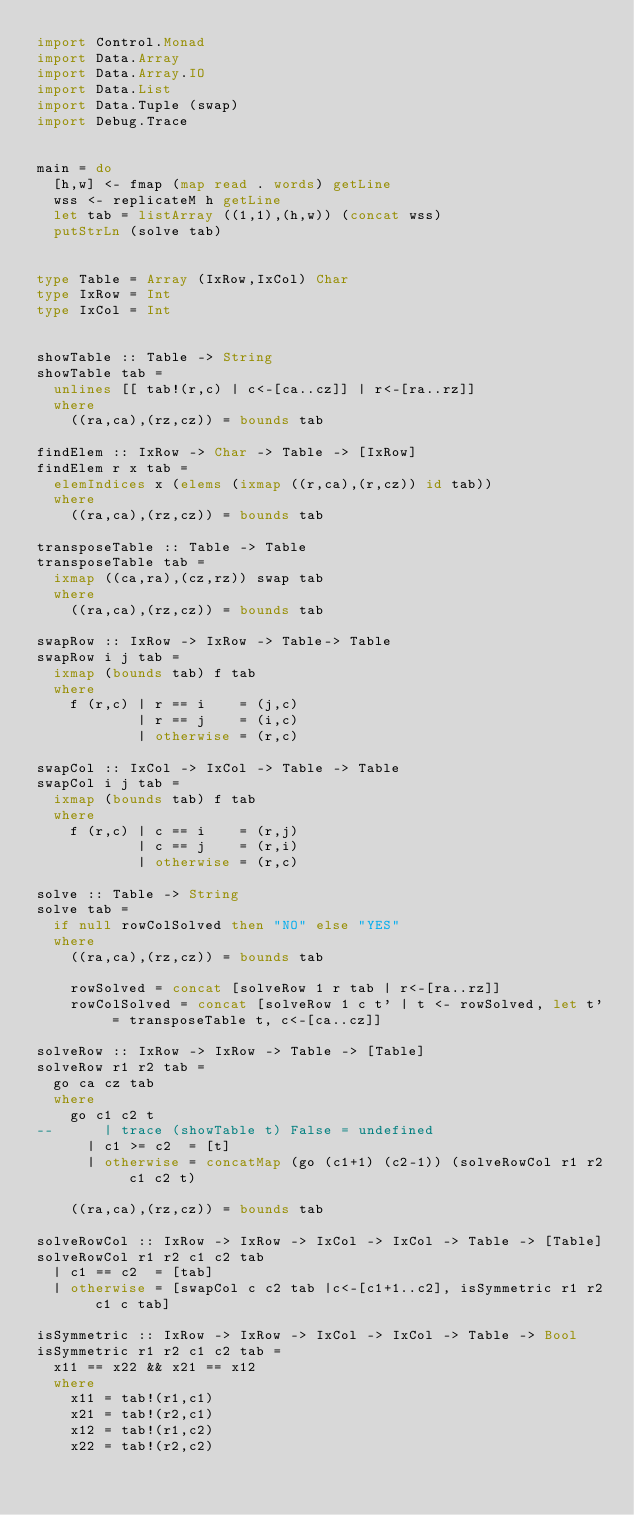Convert code to text. <code><loc_0><loc_0><loc_500><loc_500><_Haskell_>import Control.Monad
import Data.Array
import Data.Array.IO
import Data.List
import Data.Tuple (swap)
import Debug.Trace


main = do
  [h,w] <- fmap (map read . words) getLine
  wss <- replicateM h getLine
  let tab = listArray ((1,1),(h,w)) (concat wss)
  putStrLn (solve tab)


type Table = Array (IxRow,IxCol) Char
type IxRow = Int
type IxCol = Int


showTable :: Table -> String
showTable tab =
  unlines [[ tab!(r,c) | c<-[ca..cz]] | r<-[ra..rz]]
  where
    ((ra,ca),(rz,cz)) = bounds tab

findElem :: IxRow -> Char -> Table -> [IxRow]
findElem r x tab =
  elemIndices x (elems (ixmap ((r,ca),(r,cz)) id tab))
  where
    ((ra,ca),(rz,cz)) = bounds tab

transposeTable :: Table -> Table
transposeTable tab =
  ixmap ((ca,ra),(cz,rz)) swap tab
  where
    ((ra,ca),(rz,cz)) = bounds tab

swapRow :: IxRow -> IxRow -> Table-> Table
swapRow i j tab =
  ixmap (bounds tab) f tab
  where
    f (r,c) | r == i    = (j,c)
            | r == j    = (i,c)
            | otherwise = (r,c)

swapCol :: IxCol -> IxCol -> Table -> Table
swapCol i j tab =
  ixmap (bounds tab) f tab
  where
    f (r,c) | c == i    = (r,j)
            | c == j    = (r,i)
            | otherwise = (r,c)

solve :: Table -> String
solve tab =
  if null rowColSolved then "NO" else "YES"
  where
    ((ra,ca),(rz,cz)) = bounds tab

    rowSolved = concat [solveRow 1 r tab | r<-[ra..rz]]
    rowColSolved = concat [solveRow 1 c t' | t <- rowSolved, let t' = transposeTable t, c<-[ca..cz]]

solveRow :: IxRow -> IxRow -> Table -> [Table]
solveRow r1 r2 tab =
  go ca cz tab
  where
    go c1 c2 t
--      | trace (showTable t) False = undefined
      | c1 >= c2  = [t]
      | otherwise = concatMap (go (c1+1) (c2-1)) (solveRowCol r1 r2 c1 c2 t)

    ((ra,ca),(rz,cz)) = bounds tab

solveRowCol :: IxRow -> IxRow -> IxCol -> IxCol -> Table -> [Table]
solveRowCol r1 r2 c1 c2 tab
  | c1 == c2  = [tab]
  | otherwise = [swapCol c c2 tab |c<-[c1+1..c2], isSymmetric r1 r2 c1 c tab]

isSymmetric :: IxRow -> IxRow -> IxCol -> IxCol -> Table -> Bool
isSymmetric r1 r2 c1 c2 tab =
  x11 == x22 && x21 == x12
  where
    x11 = tab!(r1,c1)
    x21 = tab!(r2,c1)
    x12 = tab!(r1,c2)
    x22 = tab!(r2,c2)</code> 